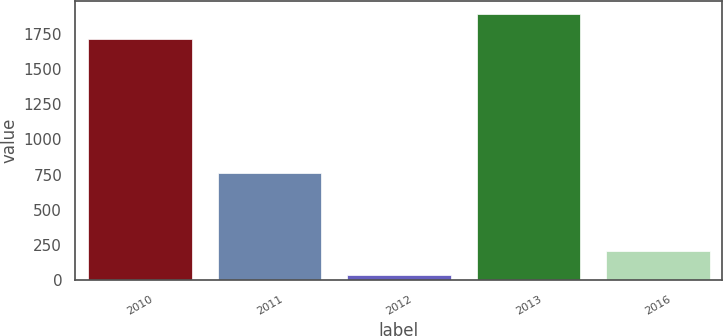Convert chart. <chart><loc_0><loc_0><loc_500><loc_500><bar_chart><fcel>2010<fcel>2011<fcel>2012<fcel>2013<fcel>2016<nl><fcel>1715<fcel>760<fcel>40<fcel>1886<fcel>211<nl></chart> 